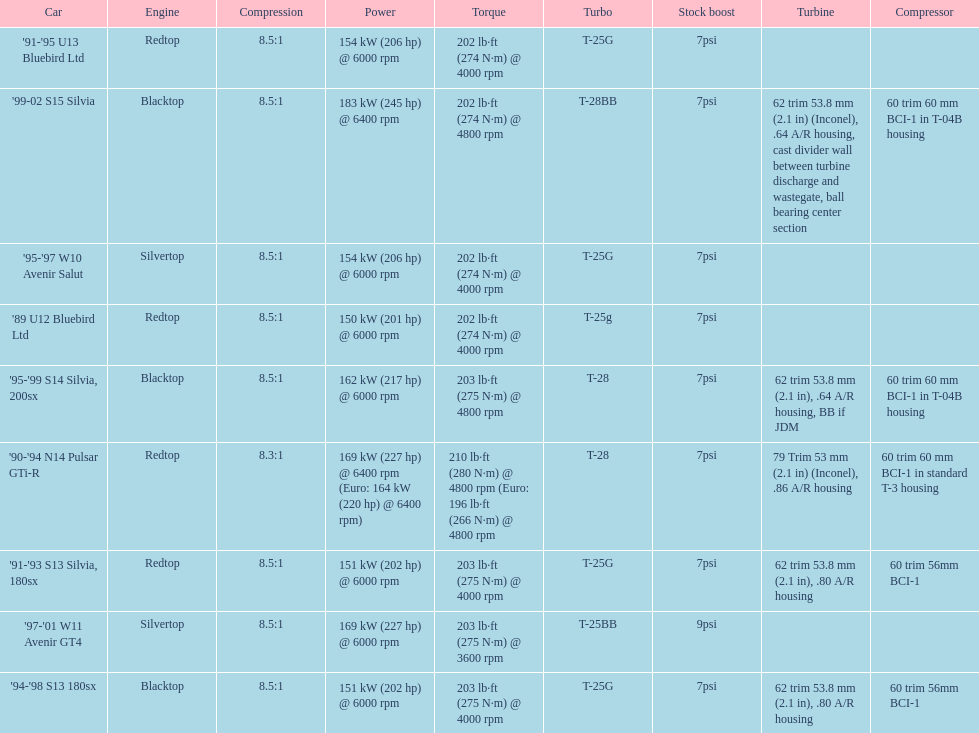Which car has a stock boost of over 7psi? '97-'01 W11 Avenir GT4. 